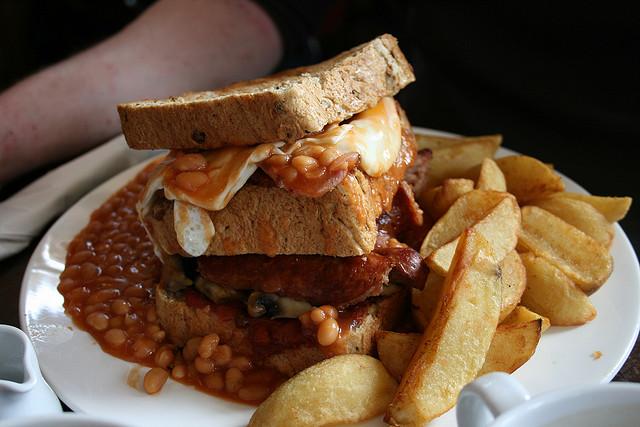What color is the plate?
Be succinct. White. Is this a healthy meal?
Write a very short answer. No. What type of food is on the plate?
Give a very brief answer. Beans. 